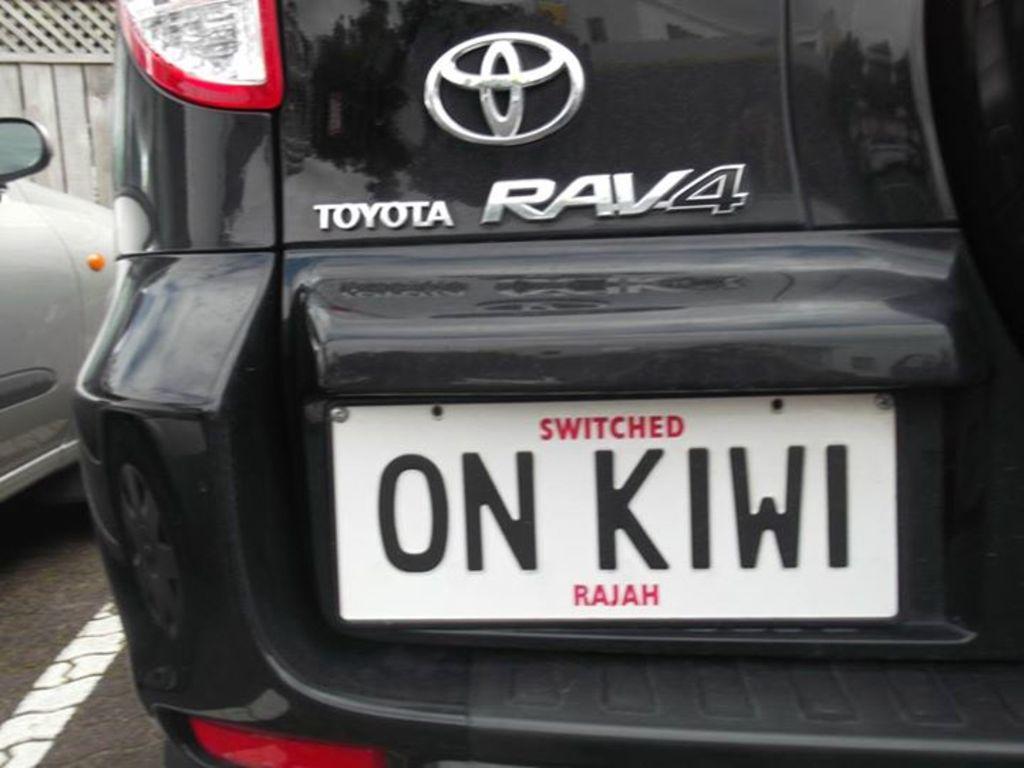What does the license plate say?
Provide a short and direct response. On kiwi. 